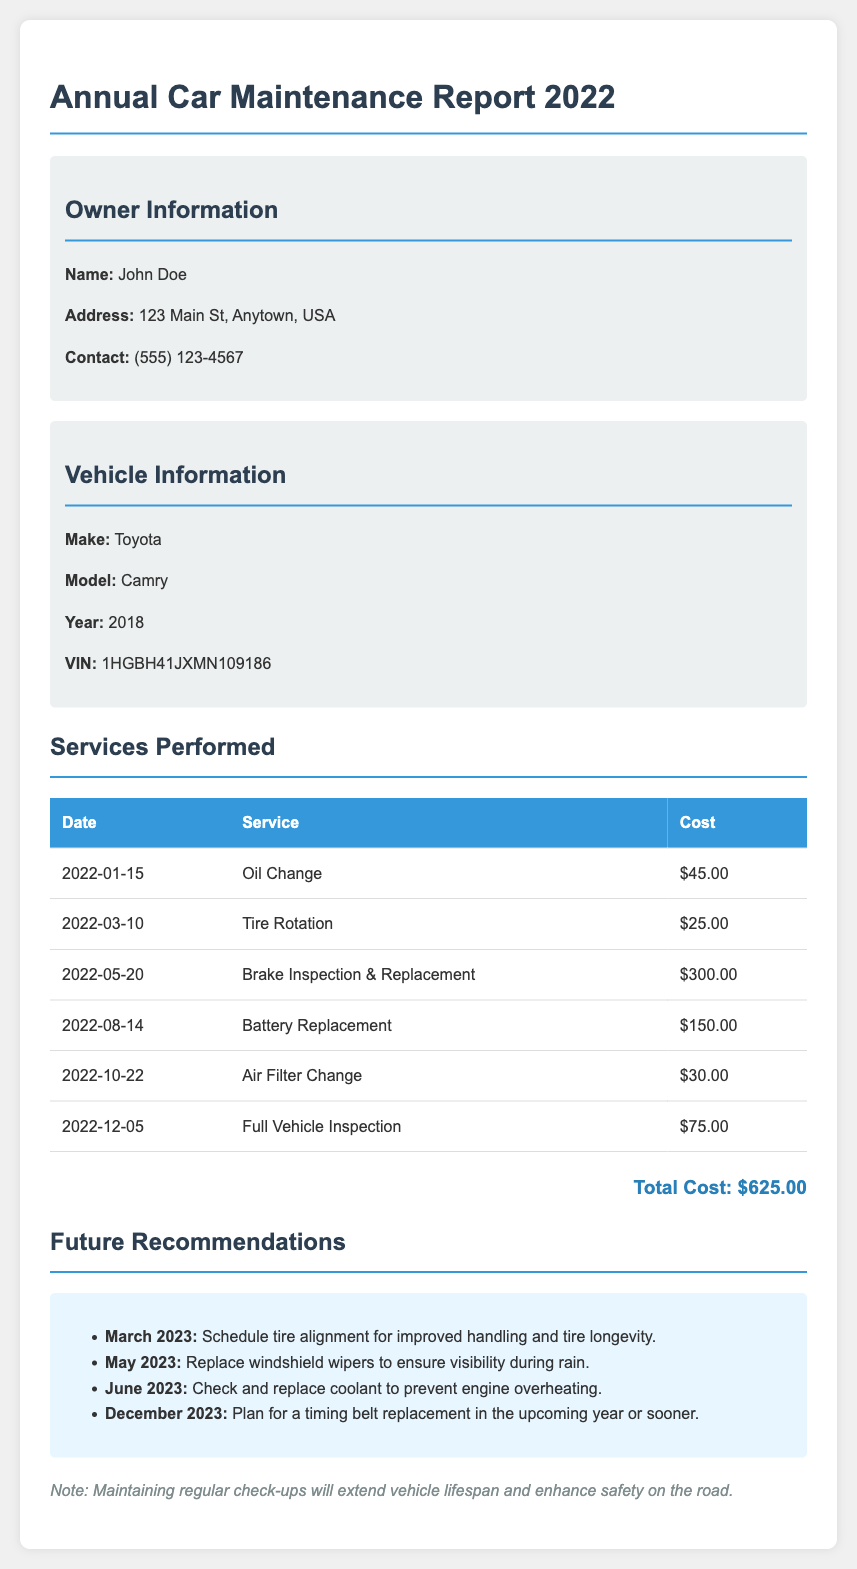What is the owner's name? The owner's name is specifically mentioned in the document under "Owner Information."
Answer: John Doe What is the total cost of services performed? The total cost is calculated and summarized at the end of the list of services performed.
Answer: $625.00 What type of vehicle is listed in the report? The type of vehicle is stated in the "Vehicle Information" section.
Answer: Toyota Camry When was the battery replaced? The date of the battery replacement is included in the table of services performed.
Answer: August 14, 2022 What recommendation is made for March 2023? The recommendations section lists future actions to be taken, starting with March 2023.
Answer: Schedule tire alignment What is the cost of the brake inspection and replacement? The specific costs for each service are detailed in the services performed table.
Answer: $300.00 What is the address of the vehicle owner? The address is provided in the owner information section.
Answer: 123 Main St, Anytown, USA Why is maintaining regular check-ups important? The note at the bottom emphasizes the importance of regular check-ups for vehicle maintenance.
Answer: Extend vehicle lifespan and enhance safety 